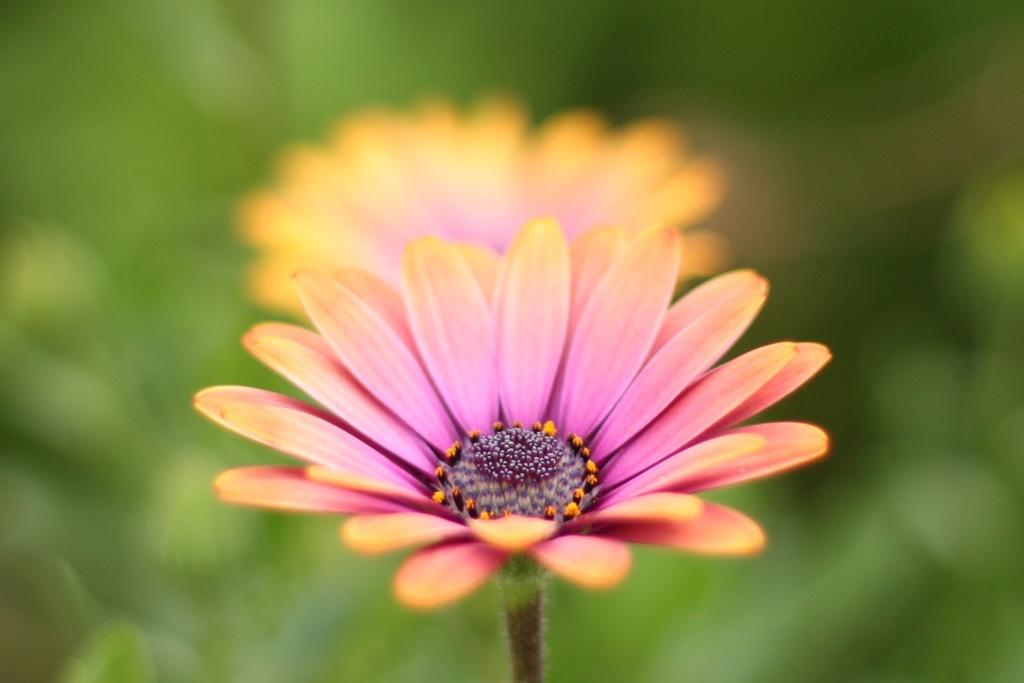What type of plants can be seen in the image? There are flowers in the image. What color are the flowers? The flowers are pink in color. How does the wind affect the mountain in the image? There is no mountain or wind present in the image; it only contains flowers. 